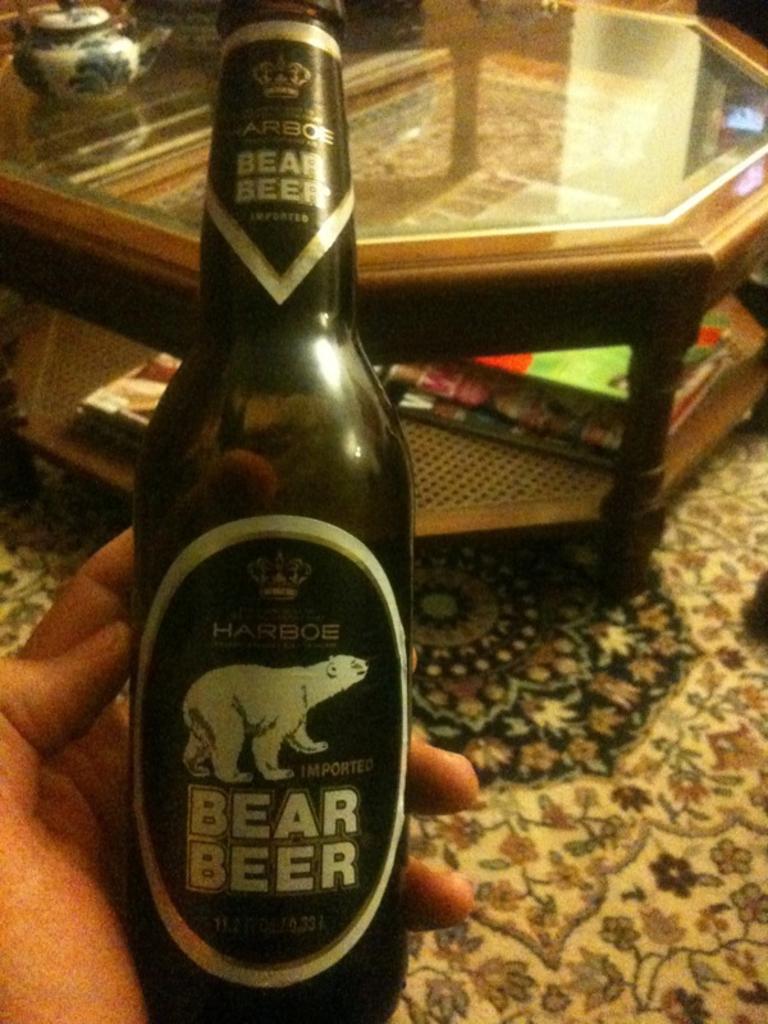In one or two sentences, can you explain what this image depicts? In this image I see a person's hand he is holding a bottle. In the background I see a table on which there are few books and a utensil. 